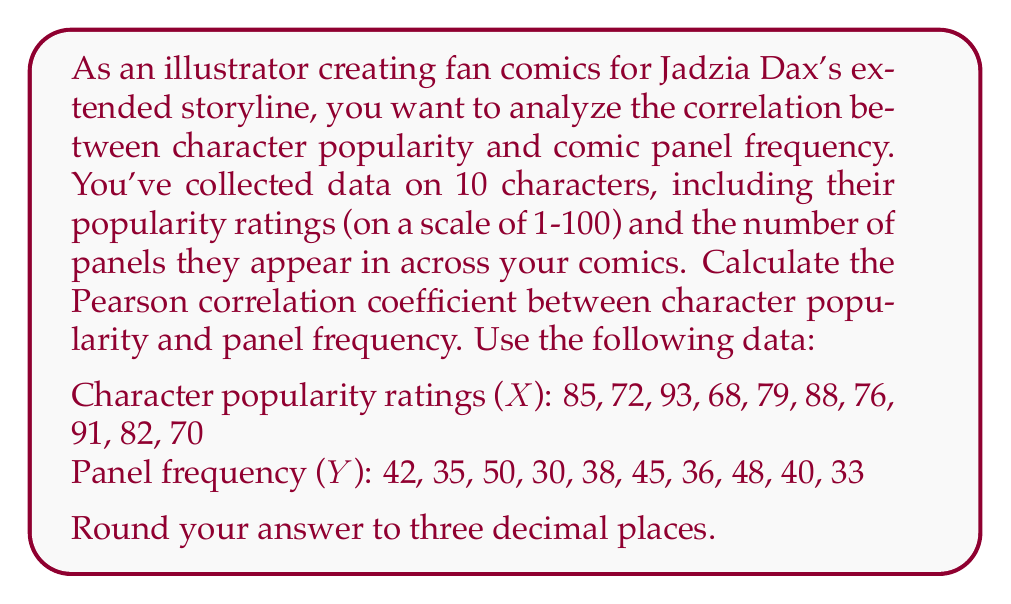Solve this math problem. To calculate the Pearson correlation coefficient (r) between character popularity (X) and panel frequency (Y), we'll use the formula:

$$ r = \frac{n\sum xy - (\sum x)(\sum y)}{\sqrt{[n\sum x^2 - (\sum x)^2][n\sum y^2 - (\sum y)^2]}} $$

Where:
n = number of pairs of data
x = character popularity ratings
y = panel frequency

Step 1: Calculate the required sums:
n = 10
$\sum x = 804$
$\sum y = 397$
$\sum xy = 32,456$
$\sum x^2 = 65,298$
$\sum y^2 = 16,013$

Step 2: Calculate $(\sum x)^2$ and $(\sum y)^2$:
$(\sum x)^2 = 804^2 = 646,416$
$(\sum y)^2 = 397^2 = 157,609$

Step 3: Apply the formula:

$$ r = \frac{10(32,456) - (804)(397)}{\sqrt{[10(65,298) - 646,416][10(16,013) - 157,609]}} $$

$$ r = \frac{324,560 - 319,188}{\sqrt{(6,564)(2,521)}} $$

$$ r = \frac{5,372}{\sqrt{16,547,844}} $$

$$ r = \frac{5,372}{4,068.64} $$

$$ r \approx 0.9760 $$

Round to three decimal places: 0.976
Answer: 0.976 